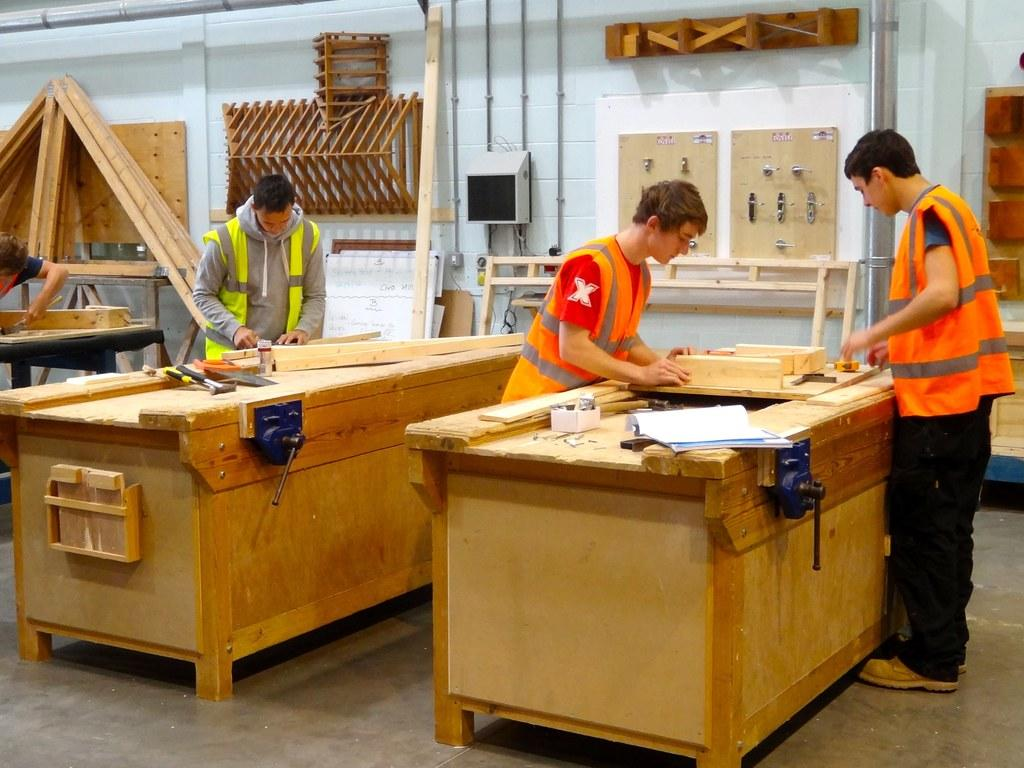What is the color of the wall in the image? The wall in the image is white. What can be seen in front of the wall? There are people standing in the image. What piece of furniture is present in the image? There is a table in the image. What type of spade is being used by the people in the image? There is no spade present in the image; the people are simply standing. 